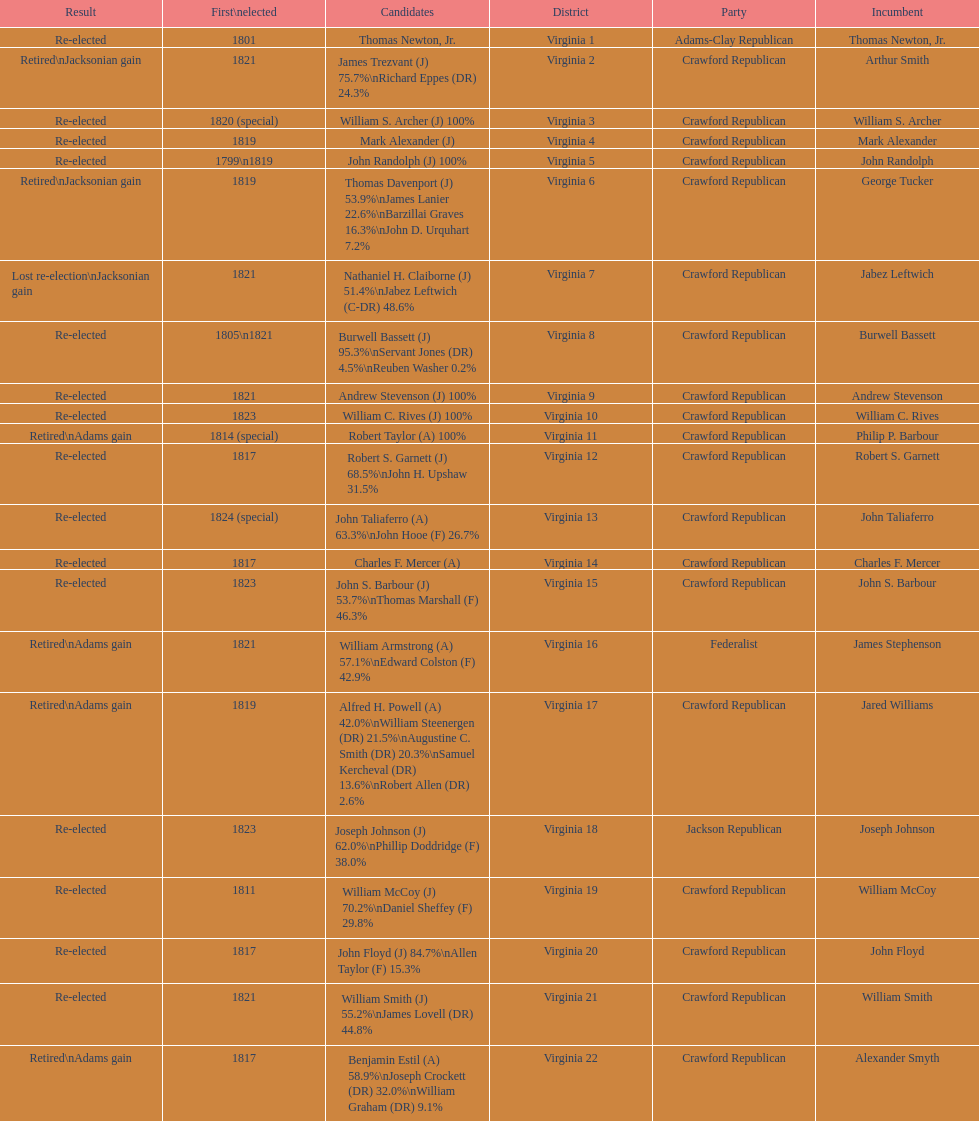How many districts are there in virginia? 22. 